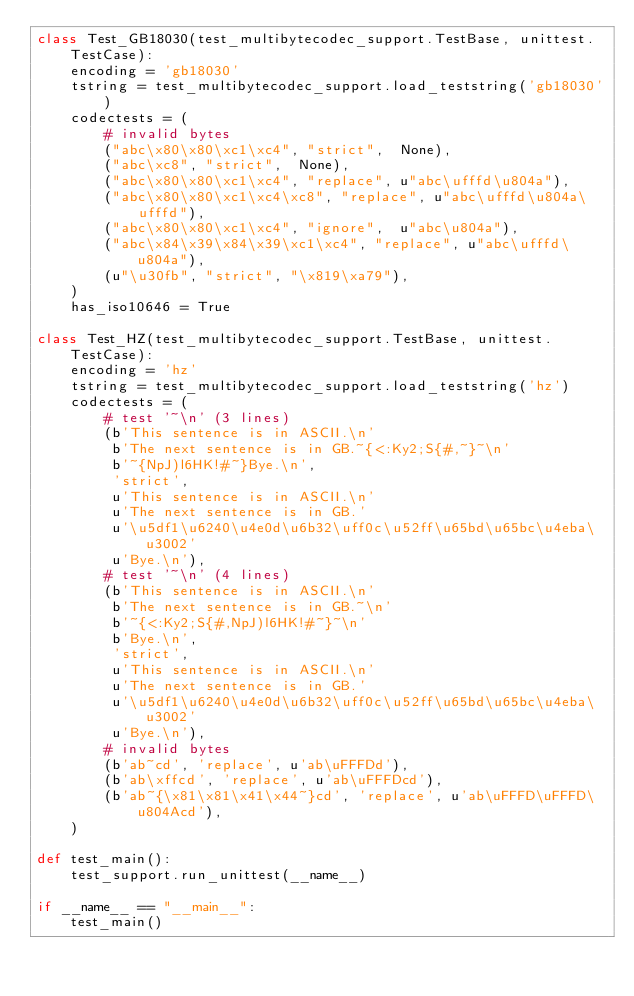<code> <loc_0><loc_0><loc_500><loc_500><_Python_>class Test_GB18030(test_multibytecodec_support.TestBase, unittest.TestCase):
    encoding = 'gb18030'
    tstring = test_multibytecodec_support.load_teststring('gb18030')
    codectests = (
        # invalid bytes
        ("abc\x80\x80\xc1\xc4", "strict",  None),
        ("abc\xc8", "strict",  None),
        ("abc\x80\x80\xc1\xc4", "replace", u"abc\ufffd\u804a"),
        ("abc\x80\x80\xc1\xc4\xc8", "replace", u"abc\ufffd\u804a\ufffd"),
        ("abc\x80\x80\xc1\xc4", "ignore",  u"abc\u804a"),
        ("abc\x84\x39\x84\x39\xc1\xc4", "replace", u"abc\ufffd\u804a"),
        (u"\u30fb", "strict", "\x819\xa79"),
    )
    has_iso10646 = True

class Test_HZ(test_multibytecodec_support.TestBase, unittest.TestCase):
    encoding = 'hz'
    tstring = test_multibytecodec_support.load_teststring('hz')
    codectests = (
        # test '~\n' (3 lines)
        (b'This sentence is in ASCII.\n'
         b'The next sentence is in GB.~{<:Ky2;S{#,~}~\n'
         b'~{NpJ)l6HK!#~}Bye.\n',
         'strict',
         u'This sentence is in ASCII.\n'
         u'The next sentence is in GB.'
         u'\u5df1\u6240\u4e0d\u6b32\uff0c\u52ff\u65bd\u65bc\u4eba\u3002'
         u'Bye.\n'),
        # test '~\n' (4 lines)
        (b'This sentence is in ASCII.\n'
         b'The next sentence is in GB.~\n'
         b'~{<:Ky2;S{#,NpJ)l6HK!#~}~\n'
         b'Bye.\n',
         'strict',
         u'This sentence is in ASCII.\n'
         u'The next sentence is in GB.'
         u'\u5df1\u6240\u4e0d\u6b32\uff0c\u52ff\u65bd\u65bc\u4eba\u3002'
         u'Bye.\n'),
        # invalid bytes
        (b'ab~cd', 'replace', u'ab\uFFFDd'),
        (b'ab\xffcd', 'replace', u'ab\uFFFDcd'),
        (b'ab~{\x81\x81\x41\x44~}cd', 'replace', u'ab\uFFFD\uFFFD\u804Acd'),
    )

def test_main():
    test_support.run_unittest(__name__)

if __name__ == "__main__":
    test_main()
</code> 